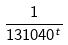Convert formula to latex. <formula><loc_0><loc_0><loc_500><loc_500>\frac { 1 } { 1 3 1 0 4 0 ^ { t } }</formula> 